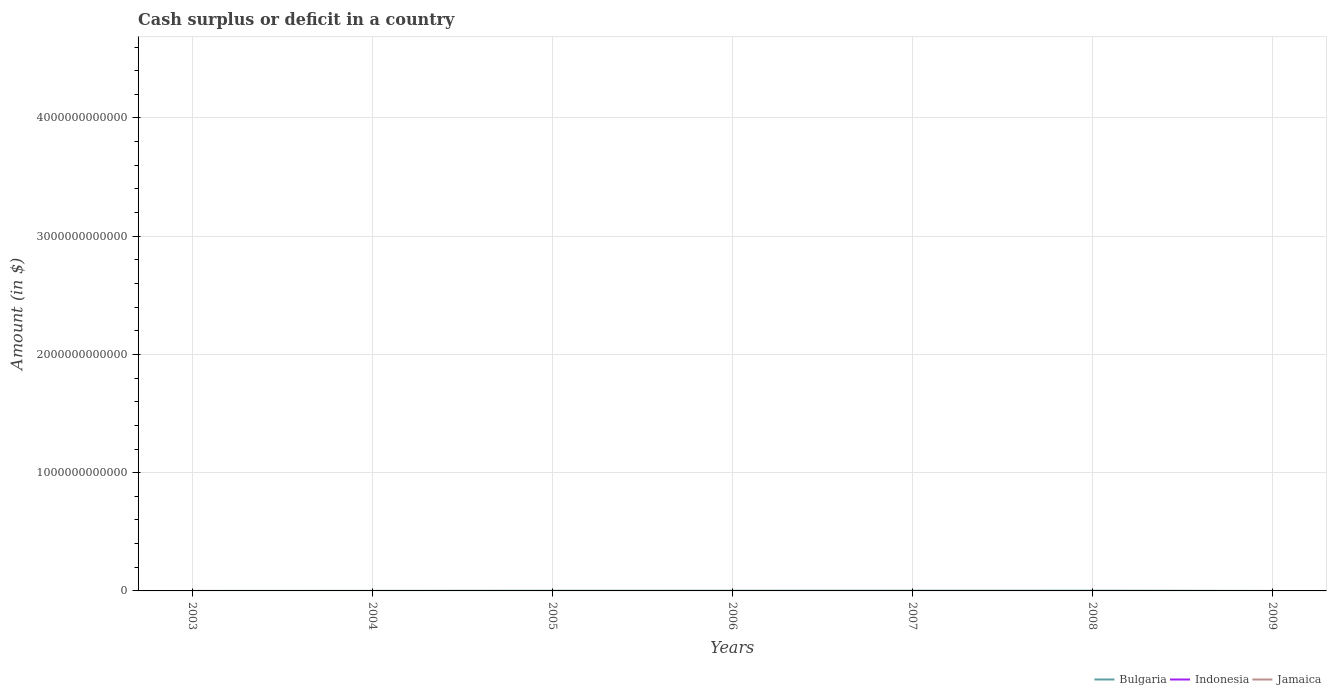Is the number of lines equal to the number of legend labels?
Make the answer very short. No. What is the total amount of cash surplus or deficit in Bulgaria in the graph?
Your answer should be compact. -1.51e+09. What is the difference between the highest and the second highest amount of cash surplus or deficit in Bulgaria?
Keep it short and to the point. 2.13e+09. How many lines are there?
Provide a short and direct response. 1. What is the difference between two consecutive major ticks on the Y-axis?
Make the answer very short. 1.00e+12. Are the values on the major ticks of Y-axis written in scientific E-notation?
Your response must be concise. No. Does the graph contain any zero values?
Your response must be concise. Yes. Does the graph contain grids?
Keep it short and to the point. Yes. Where does the legend appear in the graph?
Provide a succinct answer. Bottom right. How many legend labels are there?
Offer a terse response. 3. What is the title of the graph?
Keep it short and to the point. Cash surplus or deficit in a country. What is the label or title of the X-axis?
Your response must be concise. Years. What is the label or title of the Y-axis?
Provide a succinct answer. Amount (in $). What is the Amount (in $) in Bulgaria in 2003?
Your response must be concise. 6.74e+07. What is the Amount (in $) of Bulgaria in 2004?
Provide a succinct answer. 6.25e+08. What is the Amount (in $) in Bulgaria in 2005?
Your answer should be very brief. 1.47e+09. What is the Amount (in $) of Jamaica in 2005?
Your answer should be very brief. 0. What is the Amount (in $) of Bulgaria in 2006?
Your answer should be very brief. 1.67e+09. What is the Amount (in $) in Indonesia in 2006?
Provide a succinct answer. 0. What is the Amount (in $) in Bulgaria in 2007?
Provide a succinct answer. 2.00e+09. What is the Amount (in $) in Indonesia in 2007?
Your answer should be very brief. 0. What is the Amount (in $) in Bulgaria in 2008?
Offer a terse response. 2.13e+09. What is the Amount (in $) in Jamaica in 2008?
Give a very brief answer. 0. What is the Amount (in $) of Bulgaria in 2009?
Give a very brief answer. 0. Across all years, what is the maximum Amount (in $) in Bulgaria?
Your response must be concise. 2.13e+09. What is the total Amount (in $) of Bulgaria in the graph?
Provide a short and direct response. 7.97e+09. What is the total Amount (in $) of Indonesia in the graph?
Your answer should be very brief. 0. What is the difference between the Amount (in $) of Bulgaria in 2003 and that in 2004?
Your answer should be compact. -5.58e+08. What is the difference between the Amount (in $) in Bulgaria in 2003 and that in 2005?
Provide a succinct answer. -1.41e+09. What is the difference between the Amount (in $) in Bulgaria in 2003 and that in 2006?
Provide a succinct answer. -1.60e+09. What is the difference between the Amount (in $) in Bulgaria in 2003 and that in 2007?
Give a very brief answer. -1.94e+09. What is the difference between the Amount (in $) in Bulgaria in 2003 and that in 2008?
Offer a terse response. -2.07e+09. What is the difference between the Amount (in $) of Bulgaria in 2004 and that in 2005?
Keep it short and to the point. -8.48e+08. What is the difference between the Amount (in $) of Bulgaria in 2004 and that in 2006?
Provide a succinct answer. -1.04e+09. What is the difference between the Amount (in $) of Bulgaria in 2004 and that in 2007?
Your answer should be very brief. -1.38e+09. What is the difference between the Amount (in $) of Bulgaria in 2004 and that in 2008?
Ensure brevity in your answer.  -1.51e+09. What is the difference between the Amount (in $) in Bulgaria in 2005 and that in 2006?
Your answer should be very brief. -1.93e+08. What is the difference between the Amount (in $) in Bulgaria in 2005 and that in 2007?
Provide a short and direct response. -5.31e+08. What is the difference between the Amount (in $) in Bulgaria in 2005 and that in 2008?
Your response must be concise. -6.61e+08. What is the difference between the Amount (in $) of Bulgaria in 2006 and that in 2007?
Make the answer very short. -3.38e+08. What is the difference between the Amount (in $) of Bulgaria in 2006 and that in 2008?
Offer a terse response. -4.68e+08. What is the difference between the Amount (in $) in Bulgaria in 2007 and that in 2008?
Make the answer very short. -1.30e+08. What is the average Amount (in $) in Bulgaria per year?
Keep it short and to the point. 1.14e+09. What is the ratio of the Amount (in $) of Bulgaria in 2003 to that in 2004?
Give a very brief answer. 0.11. What is the ratio of the Amount (in $) of Bulgaria in 2003 to that in 2005?
Your answer should be compact. 0.05. What is the ratio of the Amount (in $) of Bulgaria in 2003 to that in 2006?
Your response must be concise. 0.04. What is the ratio of the Amount (in $) in Bulgaria in 2003 to that in 2007?
Provide a short and direct response. 0.03. What is the ratio of the Amount (in $) in Bulgaria in 2003 to that in 2008?
Your answer should be very brief. 0.03. What is the ratio of the Amount (in $) of Bulgaria in 2004 to that in 2005?
Your answer should be very brief. 0.42. What is the ratio of the Amount (in $) of Bulgaria in 2004 to that in 2006?
Give a very brief answer. 0.38. What is the ratio of the Amount (in $) in Bulgaria in 2004 to that in 2007?
Your answer should be compact. 0.31. What is the ratio of the Amount (in $) in Bulgaria in 2004 to that in 2008?
Your answer should be compact. 0.29. What is the ratio of the Amount (in $) in Bulgaria in 2005 to that in 2006?
Keep it short and to the point. 0.88. What is the ratio of the Amount (in $) of Bulgaria in 2005 to that in 2007?
Your response must be concise. 0.74. What is the ratio of the Amount (in $) in Bulgaria in 2005 to that in 2008?
Give a very brief answer. 0.69. What is the ratio of the Amount (in $) of Bulgaria in 2006 to that in 2007?
Your response must be concise. 0.83. What is the ratio of the Amount (in $) in Bulgaria in 2006 to that in 2008?
Make the answer very short. 0.78. What is the ratio of the Amount (in $) of Bulgaria in 2007 to that in 2008?
Offer a terse response. 0.94. What is the difference between the highest and the second highest Amount (in $) in Bulgaria?
Your response must be concise. 1.30e+08. What is the difference between the highest and the lowest Amount (in $) of Bulgaria?
Provide a succinct answer. 2.13e+09. 